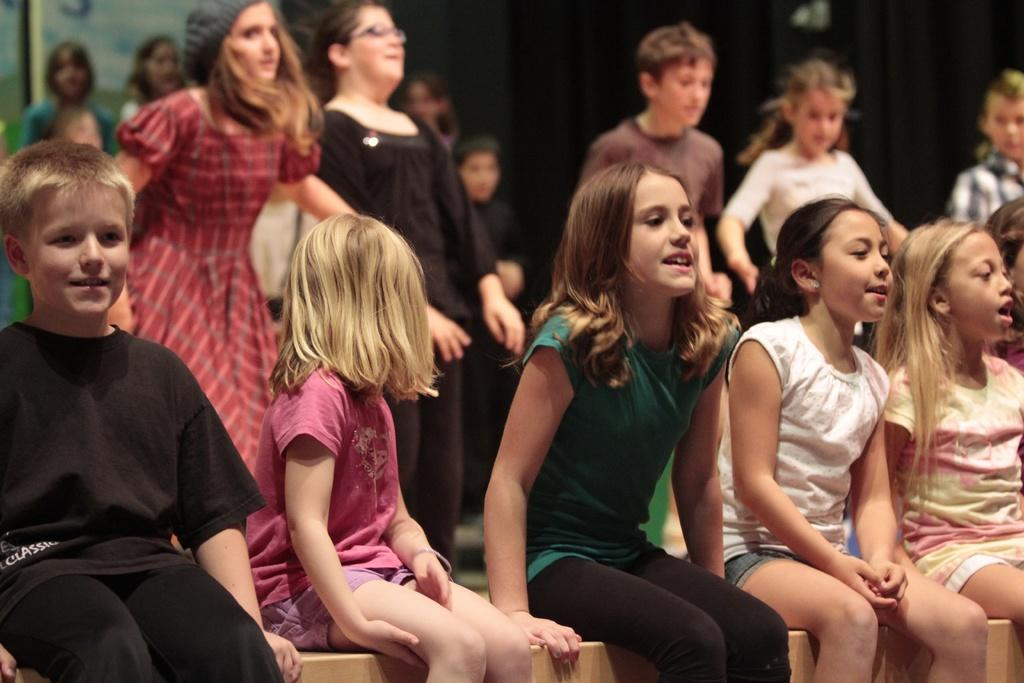What are the main subjects in the image? There are kids on a bench in the image. Can you describe the surroundings of the kids? A: There are people visible in the background of the image. What is the color of the background in the image? The background of the image appears to be black. What is the price of the transport visible in the image? There is no transport visible in the image, so it is not possible to determine its price. 